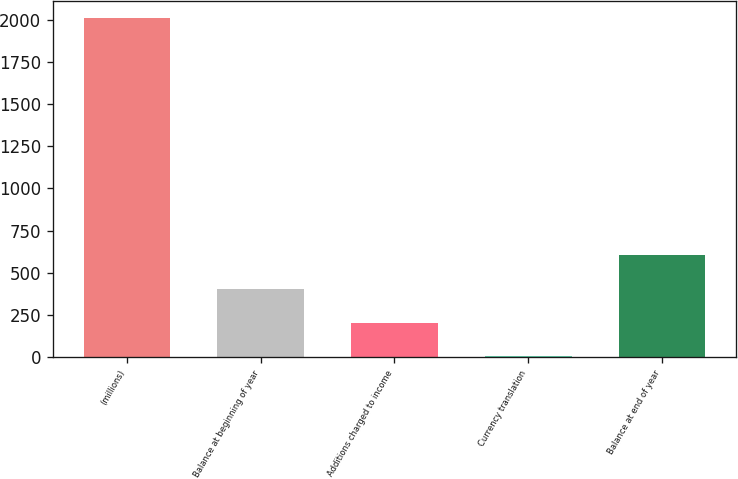Convert chart to OTSL. <chart><loc_0><loc_0><loc_500><loc_500><bar_chart><fcel>(millions)<fcel>Balance at beginning of year<fcel>Additions charged to income<fcel>Currency translation<fcel>Balance at end of year<nl><fcel>2013<fcel>404.2<fcel>203.1<fcel>2<fcel>605.3<nl></chart> 